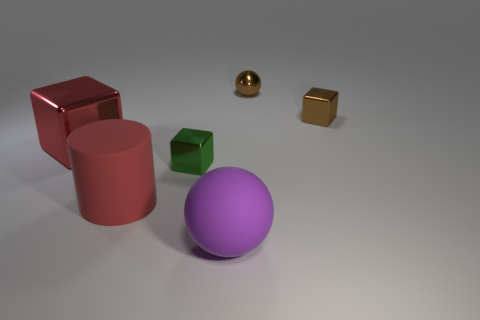There is a large purple rubber object; is it the same shape as the tiny brown shiny thing that is right of the small brown sphere?
Your answer should be very brief. No. Is there anything else that is made of the same material as the purple object?
Your response must be concise. Yes. What is the material of the red thing that is the same shape as the tiny green object?
Your answer should be compact. Metal. What number of large things are green objects or blue matte spheres?
Your response must be concise. 0. Are there fewer small green shiny objects behind the big shiny thing than tiny brown objects to the left of the big sphere?
Ensure brevity in your answer.  No. What number of things are tiny brown blocks or red objects?
Your answer should be very brief. 3. What number of tiny shiny cubes are in front of the big red shiny block?
Make the answer very short. 1. Is the large cylinder the same color as the big block?
Give a very brief answer. Yes. The red thing that is the same material as the green cube is what shape?
Provide a short and direct response. Cube. There is a small brown thing that is behind the small brown cube; is it the same shape as the small green object?
Make the answer very short. No. 